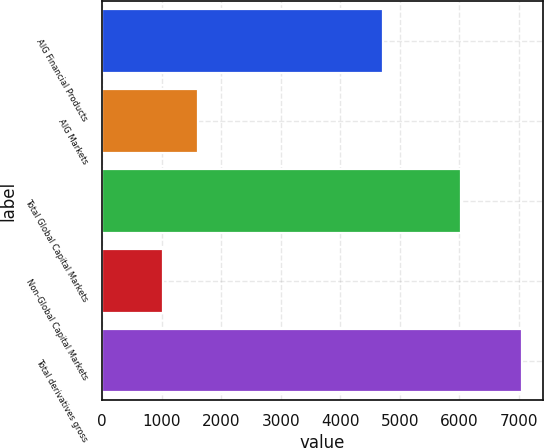<chart> <loc_0><loc_0><loc_500><loc_500><bar_chart><fcel>AIG Financial Products<fcel>AIG Markets<fcel>Total Global Capital Markets<fcel>Non-Global Capital Markets<fcel>Total derivatives gross<nl><fcel>4725<fcel>1617.3<fcel>6033<fcel>1014<fcel>7047<nl></chart> 